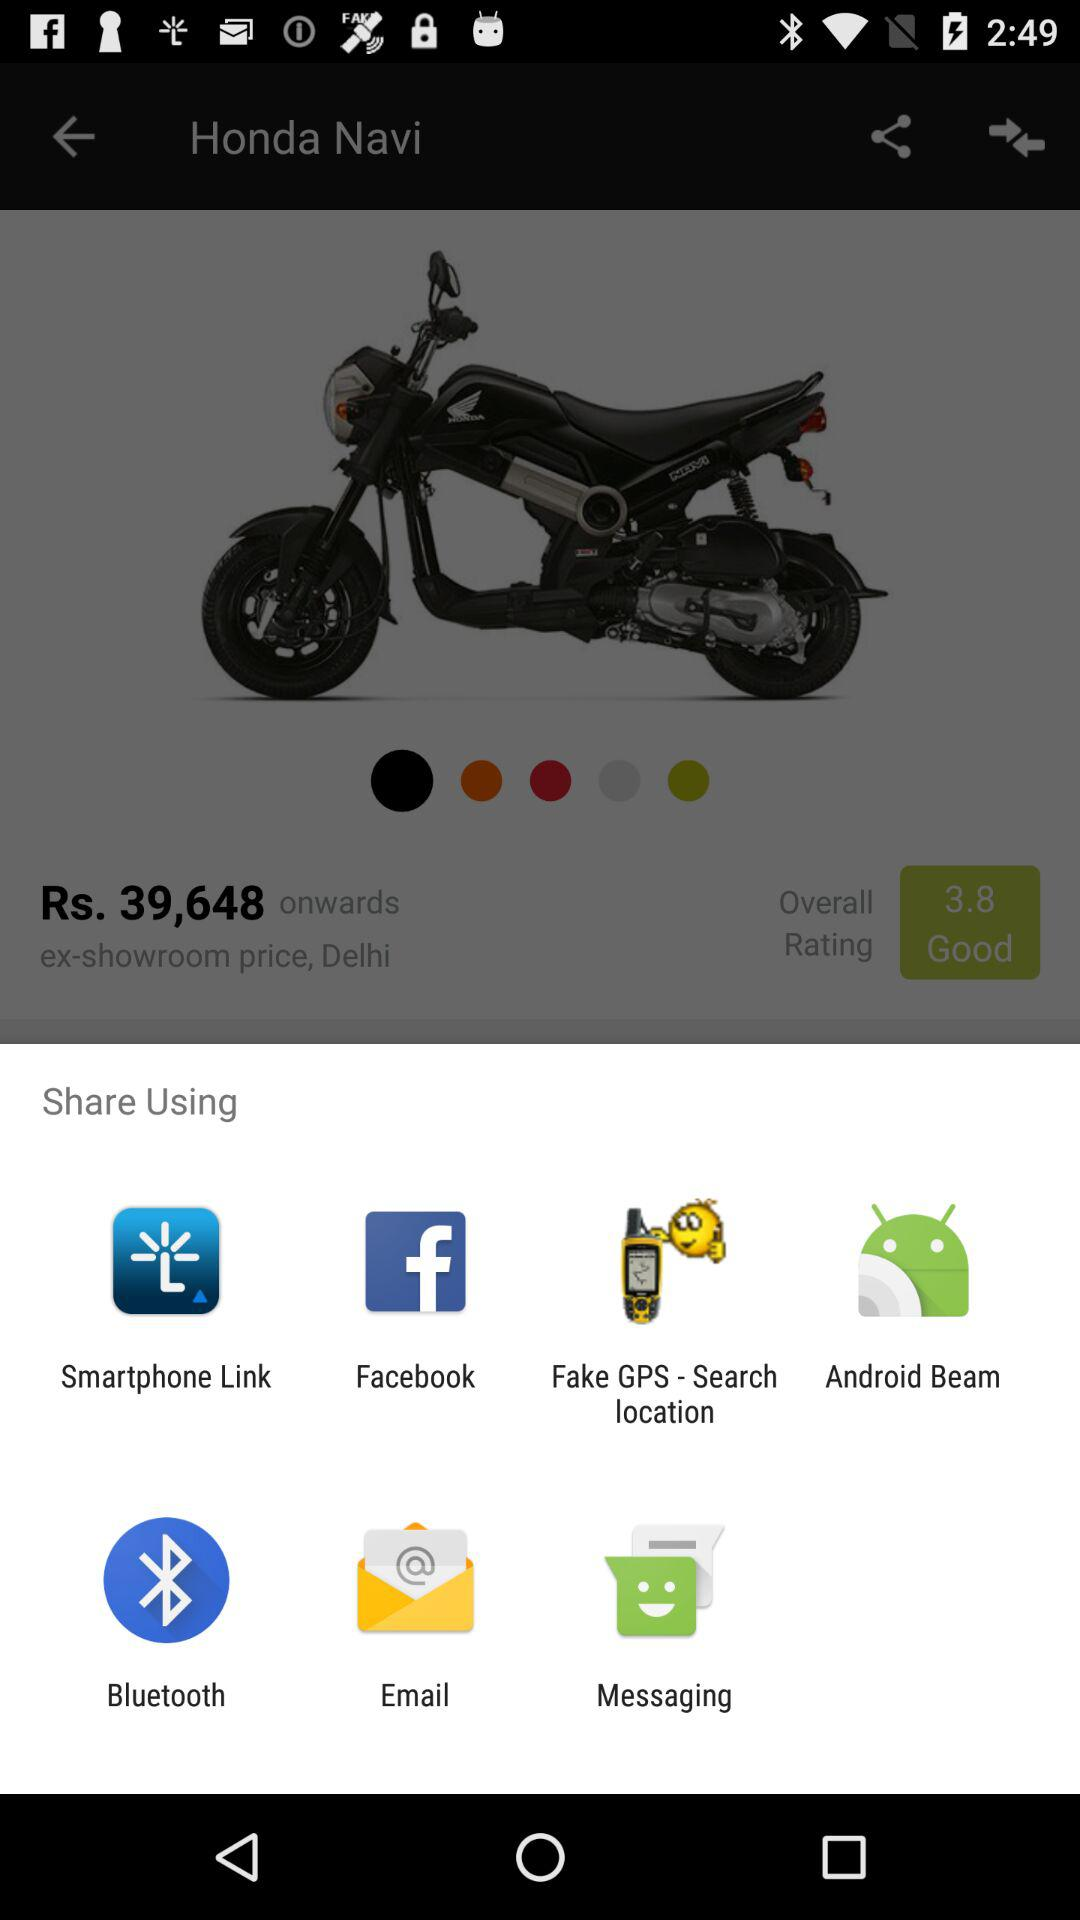What applications can be used to share? The applications that can be used to share are "Smartphone Link", "Facebook", "Fake GPS - Search location", "Android Beam", "Bluetooth", "Email" and "Messaging". 